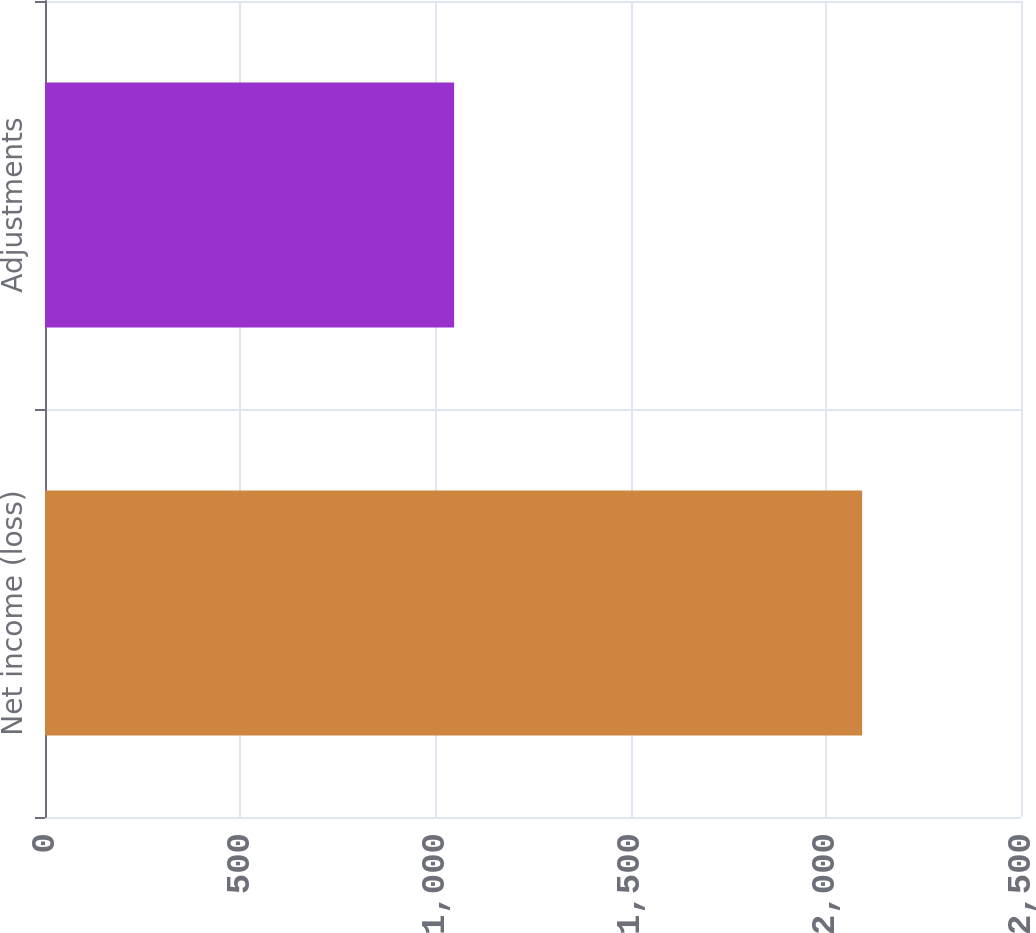Convert chart to OTSL. <chart><loc_0><loc_0><loc_500><loc_500><bar_chart><fcel>Net income (loss)<fcel>Adjustments<nl><fcel>2093<fcel>1048<nl></chart> 